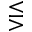<formula> <loc_0><loc_0><loc_500><loc_500>\leq s s e q g t r</formula> 